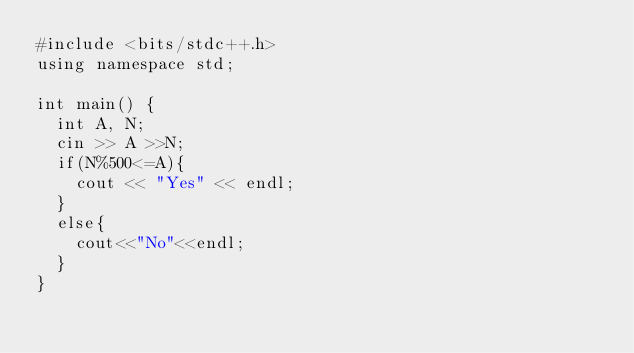Convert code to text. <code><loc_0><loc_0><loc_500><loc_500><_C++_>#include <bits/stdc++.h>
using namespace std;
 
int main() {
  int A, N;
  cin >> A >>N;
  if(N%500<=A){
    cout << "Yes" << endl;
  }
  else{
    cout<<"No"<<endl;
  }
}</code> 